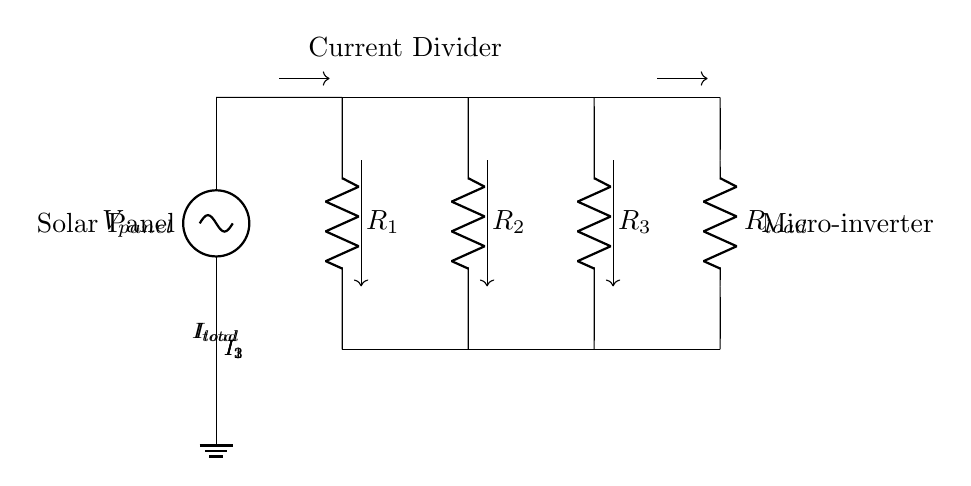What is the voltage source in the circuit? The voltage source, labeled as V panel, provides the potential difference at the top of the circuit and is connected to the solar panel.
Answer: V panel What are the resistors in the circuit? The circuit contains three resistors labeled as R1, R2, and R3, which form the current divider.
Answer: R1, R2, R3 What is the total current in this circuit? The total current, labeled I total, is the sum of the currents flowing through each of the resistors R1, R2, and R3.
Answer: I total How does the current divide among the resistors? The current divides based on the resistance values of R1, R2, and R3; according to Ohm's law, higher resistance will draw less current.
Answer: Based on resistance values What output is connected to the load? The output current labeled I load is delivered to the load resistor R load, which is connected at the right side of the current divider.
Answer: I load What type of circuit is represented here? The circuit schematic represents a current divider circuit for distributing current among multiple branches.
Answer: Current divider How can this current division benefit solar panel micro-inverters? Current division allows for optimal power harvesting by ensuring each panel operates at its maximum power point under varying conditions.
Answer: Optimal power harvesting 